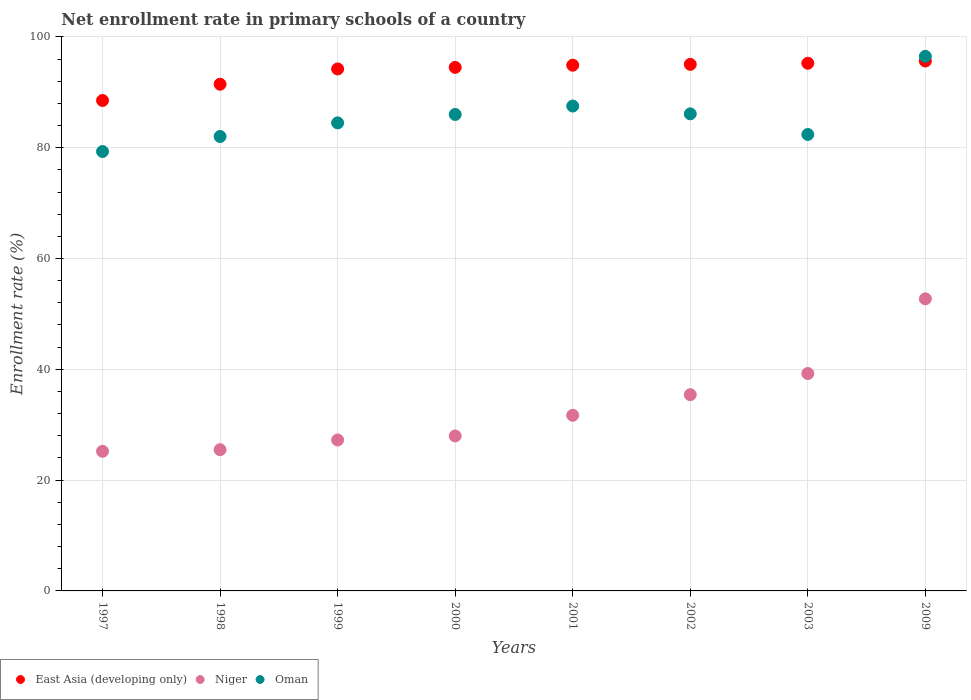What is the enrollment rate in primary schools in East Asia (developing only) in 1998?
Offer a very short reply. 91.46. Across all years, what is the maximum enrollment rate in primary schools in Niger?
Your answer should be very brief. 52.72. Across all years, what is the minimum enrollment rate in primary schools in Oman?
Make the answer very short. 79.31. In which year was the enrollment rate in primary schools in East Asia (developing only) minimum?
Your answer should be compact. 1997. What is the total enrollment rate in primary schools in Oman in the graph?
Your response must be concise. 684.31. What is the difference between the enrollment rate in primary schools in East Asia (developing only) in 1999 and that in 2009?
Offer a terse response. -1.43. What is the difference between the enrollment rate in primary schools in Niger in 2002 and the enrollment rate in primary schools in East Asia (developing only) in 2001?
Keep it short and to the point. -59.47. What is the average enrollment rate in primary schools in Oman per year?
Your answer should be compact. 85.54. In the year 2000, what is the difference between the enrollment rate in primary schools in Oman and enrollment rate in primary schools in Niger?
Make the answer very short. 58.03. What is the ratio of the enrollment rate in primary schools in East Asia (developing only) in 2002 to that in 2009?
Keep it short and to the point. 0.99. What is the difference between the highest and the second highest enrollment rate in primary schools in Oman?
Your response must be concise. 8.97. What is the difference between the highest and the lowest enrollment rate in primary schools in Niger?
Give a very brief answer. 27.52. Is the sum of the enrollment rate in primary schools in East Asia (developing only) in 1998 and 2000 greater than the maximum enrollment rate in primary schools in Niger across all years?
Your response must be concise. Yes. Does the enrollment rate in primary schools in Oman monotonically increase over the years?
Offer a terse response. No. Is the enrollment rate in primary schools in East Asia (developing only) strictly greater than the enrollment rate in primary schools in Niger over the years?
Provide a succinct answer. Yes. Is the enrollment rate in primary schools in Oman strictly less than the enrollment rate in primary schools in East Asia (developing only) over the years?
Your answer should be compact. No. How many years are there in the graph?
Offer a very short reply. 8. Are the values on the major ticks of Y-axis written in scientific E-notation?
Your answer should be very brief. No. Does the graph contain grids?
Provide a succinct answer. Yes. Where does the legend appear in the graph?
Offer a terse response. Bottom left. What is the title of the graph?
Give a very brief answer. Net enrollment rate in primary schools of a country. Does "St. Lucia" appear as one of the legend labels in the graph?
Your response must be concise. No. What is the label or title of the X-axis?
Offer a terse response. Years. What is the label or title of the Y-axis?
Your response must be concise. Enrollment rate (%). What is the Enrollment rate (%) in East Asia (developing only) in 1997?
Your answer should be very brief. 88.52. What is the Enrollment rate (%) of Niger in 1997?
Offer a terse response. 25.2. What is the Enrollment rate (%) of Oman in 1997?
Make the answer very short. 79.31. What is the Enrollment rate (%) of East Asia (developing only) in 1998?
Offer a very short reply. 91.46. What is the Enrollment rate (%) in Niger in 1998?
Ensure brevity in your answer.  25.49. What is the Enrollment rate (%) of Oman in 1998?
Ensure brevity in your answer.  82.02. What is the Enrollment rate (%) in East Asia (developing only) in 1999?
Make the answer very short. 94.21. What is the Enrollment rate (%) in Niger in 1999?
Offer a very short reply. 27.24. What is the Enrollment rate (%) in Oman in 1999?
Keep it short and to the point. 84.48. What is the Enrollment rate (%) in East Asia (developing only) in 2000?
Keep it short and to the point. 94.5. What is the Enrollment rate (%) in Niger in 2000?
Your answer should be compact. 27.97. What is the Enrollment rate (%) of Oman in 2000?
Ensure brevity in your answer.  86. What is the Enrollment rate (%) in East Asia (developing only) in 2001?
Your response must be concise. 94.89. What is the Enrollment rate (%) of Niger in 2001?
Your answer should be very brief. 31.7. What is the Enrollment rate (%) in Oman in 2001?
Provide a succinct answer. 87.52. What is the Enrollment rate (%) in East Asia (developing only) in 2002?
Make the answer very short. 95.04. What is the Enrollment rate (%) of Niger in 2002?
Your answer should be very brief. 35.42. What is the Enrollment rate (%) in Oman in 2002?
Make the answer very short. 86.11. What is the Enrollment rate (%) in East Asia (developing only) in 2003?
Make the answer very short. 95.24. What is the Enrollment rate (%) in Niger in 2003?
Provide a short and direct response. 39.24. What is the Enrollment rate (%) in Oman in 2003?
Offer a very short reply. 82.39. What is the Enrollment rate (%) in East Asia (developing only) in 2009?
Provide a succinct answer. 95.64. What is the Enrollment rate (%) of Niger in 2009?
Ensure brevity in your answer.  52.72. What is the Enrollment rate (%) of Oman in 2009?
Your answer should be compact. 96.49. Across all years, what is the maximum Enrollment rate (%) in East Asia (developing only)?
Offer a terse response. 95.64. Across all years, what is the maximum Enrollment rate (%) of Niger?
Your answer should be compact. 52.72. Across all years, what is the maximum Enrollment rate (%) in Oman?
Your answer should be very brief. 96.49. Across all years, what is the minimum Enrollment rate (%) in East Asia (developing only)?
Offer a terse response. 88.52. Across all years, what is the minimum Enrollment rate (%) of Niger?
Your answer should be very brief. 25.2. Across all years, what is the minimum Enrollment rate (%) in Oman?
Make the answer very short. 79.31. What is the total Enrollment rate (%) of East Asia (developing only) in the graph?
Provide a short and direct response. 749.5. What is the total Enrollment rate (%) in Niger in the graph?
Make the answer very short. 264.98. What is the total Enrollment rate (%) in Oman in the graph?
Ensure brevity in your answer.  684.31. What is the difference between the Enrollment rate (%) in East Asia (developing only) in 1997 and that in 1998?
Give a very brief answer. -2.93. What is the difference between the Enrollment rate (%) of Niger in 1997 and that in 1998?
Make the answer very short. -0.29. What is the difference between the Enrollment rate (%) in Oman in 1997 and that in 1998?
Offer a very short reply. -2.71. What is the difference between the Enrollment rate (%) in East Asia (developing only) in 1997 and that in 1999?
Offer a terse response. -5.69. What is the difference between the Enrollment rate (%) in Niger in 1997 and that in 1999?
Offer a terse response. -2.04. What is the difference between the Enrollment rate (%) of Oman in 1997 and that in 1999?
Offer a very short reply. -5.17. What is the difference between the Enrollment rate (%) in East Asia (developing only) in 1997 and that in 2000?
Give a very brief answer. -5.97. What is the difference between the Enrollment rate (%) of Niger in 1997 and that in 2000?
Offer a very short reply. -2.77. What is the difference between the Enrollment rate (%) of Oman in 1997 and that in 2000?
Your answer should be compact. -6.69. What is the difference between the Enrollment rate (%) of East Asia (developing only) in 1997 and that in 2001?
Keep it short and to the point. -6.37. What is the difference between the Enrollment rate (%) in Niger in 1997 and that in 2001?
Ensure brevity in your answer.  -6.5. What is the difference between the Enrollment rate (%) of Oman in 1997 and that in 2001?
Your answer should be very brief. -8.21. What is the difference between the Enrollment rate (%) of East Asia (developing only) in 1997 and that in 2002?
Your response must be concise. -6.52. What is the difference between the Enrollment rate (%) of Niger in 1997 and that in 2002?
Give a very brief answer. -10.22. What is the difference between the Enrollment rate (%) in Oman in 1997 and that in 2002?
Offer a very short reply. -6.8. What is the difference between the Enrollment rate (%) in East Asia (developing only) in 1997 and that in 2003?
Provide a succinct answer. -6.72. What is the difference between the Enrollment rate (%) of Niger in 1997 and that in 2003?
Offer a very short reply. -14.04. What is the difference between the Enrollment rate (%) in Oman in 1997 and that in 2003?
Keep it short and to the point. -3.08. What is the difference between the Enrollment rate (%) of East Asia (developing only) in 1997 and that in 2009?
Offer a very short reply. -7.12. What is the difference between the Enrollment rate (%) in Niger in 1997 and that in 2009?
Make the answer very short. -27.52. What is the difference between the Enrollment rate (%) in Oman in 1997 and that in 2009?
Ensure brevity in your answer.  -17.18. What is the difference between the Enrollment rate (%) in East Asia (developing only) in 1998 and that in 1999?
Your answer should be compact. -2.76. What is the difference between the Enrollment rate (%) of Niger in 1998 and that in 1999?
Ensure brevity in your answer.  -1.75. What is the difference between the Enrollment rate (%) in Oman in 1998 and that in 1999?
Make the answer very short. -2.46. What is the difference between the Enrollment rate (%) in East Asia (developing only) in 1998 and that in 2000?
Your answer should be compact. -3.04. What is the difference between the Enrollment rate (%) in Niger in 1998 and that in 2000?
Give a very brief answer. -2.48. What is the difference between the Enrollment rate (%) of Oman in 1998 and that in 2000?
Your response must be concise. -3.98. What is the difference between the Enrollment rate (%) of East Asia (developing only) in 1998 and that in 2001?
Your answer should be compact. -3.43. What is the difference between the Enrollment rate (%) in Niger in 1998 and that in 2001?
Keep it short and to the point. -6.21. What is the difference between the Enrollment rate (%) in Oman in 1998 and that in 2001?
Provide a short and direct response. -5.5. What is the difference between the Enrollment rate (%) in East Asia (developing only) in 1998 and that in 2002?
Keep it short and to the point. -3.58. What is the difference between the Enrollment rate (%) in Niger in 1998 and that in 2002?
Offer a terse response. -9.93. What is the difference between the Enrollment rate (%) in Oman in 1998 and that in 2002?
Make the answer very short. -4.09. What is the difference between the Enrollment rate (%) in East Asia (developing only) in 1998 and that in 2003?
Offer a very short reply. -3.79. What is the difference between the Enrollment rate (%) in Niger in 1998 and that in 2003?
Offer a terse response. -13.75. What is the difference between the Enrollment rate (%) of Oman in 1998 and that in 2003?
Offer a very short reply. -0.37. What is the difference between the Enrollment rate (%) of East Asia (developing only) in 1998 and that in 2009?
Your answer should be very brief. -4.19. What is the difference between the Enrollment rate (%) in Niger in 1998 and that in 2009?
Ensure brevity in your answer.  -27.23. What is the difference between the Enrollment rate (%) in Oman in 1998 and that in 2009?
Offer a very short reply. -14.47. What is the difference between the Enrollment rate (%) in East Asia (developing only) in 1999 and that in 2000?
Ensure brevity in your answer.  -0.28. What is the difference between the Enrollment rate (%) in Niger in 1999 and that in 2000?
Your answer should be very brief. -0.73. What is the difference between the Enrollment rate (%) in Oman in 1999 and that in 2000?
Your answer should be very brief. -1.52. What is the difference between the Enrollment rate (%) in East Asia (developing only) in 1999 and that in 2001?
Provide a short and direct response. -0.68. What is the difference between the Enrollment rate (%) in Niger in 1999 and that in 2001?
Provide a short and direct response. -4.46. What is the difference between the Enrollment rate (%) of Oman in 1999 and that in 2001?
Offer a very short reply. -3.04. What is the difference between the Enrollment rate (%) of East Asia (developing only) in 1999 and that in 2002?
Give a very brief answer. -0.83. What is the difference between the Enrollment rate (%) in Niger in 1999 and that in 2002?
Your response must be concise. -8.18. What is the difference between the Enrollment rate (%) of Oman in 1999 and that in 2002?
Give a very brief answer. -1.63. What is the difference between the Enrollment rate (%) of East Asia (developing only) in 1999 and that in 2003?
Offer a very short reply. -1.03. What is the difference between the Enrollment rate (%) of Niger in 1999 and that in 2003?
Make the answer very short. -12. What is the difference between the Enrollment rate (%) in Oman in 1999 and that in 2003?
Offer a very short reply. 2.09. What is the difference between the Enrollment rate (%) in East Asia (developing only) in 1999 and that in 2009?
Provide a short and direct response. -1.43. What is the difference between the Enrollment rate (%) in Niger in 1999 and that in 2009?
Keep it short and to the point. -25.47. What is the difference between the Enrollment rate (%) of Oman in 1999 and that in 2009?
Give a very brief answer. -12.01. What is the difference between the Enrollment rate (%) in East Asia (developing only) in 2000 and that in 2001?
Provide a short and direct response. -0.39. What is the difference between the Enrollment rate (%) of Niger in 2000 and that in 2001?
Offer a very short reply. -3.73. What is the difference between the Enrollment rate (%) in Oman in 2000 and that in 2001?
Offer a terse response. -1.52. What is the difference between the Enrollment rate (%) of East Asia (developing only) in 2000 and that in 2002?
Make the answer very short. -0.54. What is the difference between the Enrollment rate (%) in Niger in 2000 and that in 2002?
Your response must be concise. -7.45. What is the difference between the Enrollment rate (%) of Oman in 2000 and that in 2002?
Offer a very short reply. -0.11. What is the difference between the Enrollment rate (%) of East Asia (developing only) in 2000 and that in 2003?
Your response must be concise. -0.75. What is the difference between the Enrollment rate (%) of Niger in 2000 and that in 2003?
Offer a terse response. -11.27. What is the difference between the Enrollment rate (%) of Oman in 2000 and that in 2003?
Your response must be concise. 3.61. What is the difference between the Enrollment rate (%) of East Asia (developing only) in 2000 and that in 2009?
Offer a very short reply. -1.15. What is the difference between the Enrollment rate (%) in Niger in 2000 and that in 2009?
Provide a short and direct response. -24.75. What is the difference between the Enrollment rate (%) of Oman in 2000 and that in 2009?
Offer a very short reply. -10.49. What is the difference between the Enrollment rate (%) of East Asia (developing only) in 2001 and that in 2002?
Provide a succinct answer. -0.15. What is the difference between the Enrollment rate (%) in Niger in 2001 and that in 2002?
Provide a short and direct response. -3.72. What is the difference between the Enrollment rate (%) in Oman in 2001 and that in 2002?
Offer a very short reply. 1.41. What is the difference between the Enrollment rate (%) of East Asia (developing only) in 2001 and that in 2003?
Keep it short and to the point. -0.35. What is the difference between the Enrollment rate (%) in Niger in 2001 and that in 2003?
Offer a very short reply. -7.54. What is the difference between the Enrollment rate (%) of Oman in 2001 and that in 2003?
Provide a short and direct response. 5.13. What is the difference between the Enrollment rate (%) of East Asia (developing only) in 2001 and that in 2009?
Offer a very short reply. -0.76. What is the difference between the Enrollment rate (%) in Niger in 2001 and that in 2009?
Offer a terse response. -21.02. What is the difference between the Enrollment rate (%) of Oman in 2001 and that in 2009?
Offer a very short reply. -8.97. What is the difference between the Enrollment rate (%) in East Asia (developing only) in 2002 and that in 2003?
Ensure brevity in your answer.  -0.2. What is the difference between the Enrollment rate (%) in Niger in 2002 and that in 2003?
Provide a succinct answer. -3.82. What is the difference between the Enrollment rate (%) of Oman in 2002 and that in 2003?
Provide a short and direct response. 3.73. What is the difference between the Enrollment rate (%) of East Asia (developing only) in 2002 and that in 2009?
Ensure brevity in your answer.  -0.6. What is the difference between the Enrollment rate (%) of Niger in 2002 and that in 2009?
Offer a terse response. -17.3. What is the difference between the Enrollment rate (%) in Oman in 2002 and that in 2009?
Make the answer very short. -10.38. What is the difference between the Enrollment rate (%) of East Asia (developing only) in 2003 and that in 2009?
Provide a short and direct response. -0.4. What is the difference between the Enrollment rate (%) in Niger in 2003 and that in 2009?
Offer a very short reply. -13.48. What is the difference between the Enrollment rate (%) in Oman in 2003 and that in 2009?
Give a very brief answer. -14.1. What is the difference between the Enrollment rate (%) of East Asia (developing only) in 1997 and the Enrollment rate (%) of Niger in 1998?
Your answer should be compact. 63.03. What is the difference between the Enrollment rate (%) in East Asia (developing only) in 1997 and the Enrollment rate (%) in Oman in 1998?
Your answer should be compact. 6.5. What is the difference between the Enrollment rate (%) in Niger in 1997 and the Enrollment rate (%) in Oman in 1998?
Offer a terse response. -56.82. What is the difference between the Enrollment rate (%) of East Asia (developing only) in 1997 and the Enrollment rate (%) of Niger in 1999?
Give a very brief answer. 61.28. What is the difference between the Enrollment rate (%) in East Asia (developing only) in 1997 and the Enrollment rate (%) in Oman in 1999?
Keep it short and to the point. 4.04. What is the difference between the Enrollment rate (%) in Niger in 1997 and the Enrollment rate (%) in Oman in 1999?
Your response must be concise. -59.28. What is the difference between the Enrollment rate (%) in East Asia (developing only) in 1997 and the Enrollment rate (%) in Niger in 2000?
Give a very brief answer. 60.55. What is the difference between the Enrollment rate (%) of East Asia (developing only) in 1997 and the Enrollment rate (%) of Oman in 2000?
Make the answer very short. 2.52. What is the difference between the Enrollment rate (%) of Niger in 1997 and the Enrollment rate (%) of Oman in 2000?
Offer a terse response. -60.8. What is the difference between the Enrollment rate (%) in East Asia (developing only) in 1997 and the Enrollment rate (%) in Niger in 2001?
Give a very brief answer. 56.82. What is the difference between the Enrollment rate (%) of East Asia (developing only) in 1997 and the Enrollment rate (%) of Oman in 2001?
Give a very brief answer. 1. What is the difference between the Enrollment rate (%) in Niger in 1997 and the Enrollment rate (%) in Oman in 2001?
Make the answer very short. -62.32. What is the difference between the Enrollment rate (%) in East Asia (developing only) in 1997 and the Enrollment rate (%) in Niger in 2002?
Keep it short and to the point. 53.1. What is the difference between the Enrollment rate (%) in East Asia (developing only) in 1997 and the Enrollment rate (%) in Oman in 2002?
Keep it short and to the point. 2.41. What is the difference between the Enrollment rate (%) of Niger in 1997 and the Enrollment rate (%) of Oman in 2002?
Offer a very short reply. -60.91. What is the difference between the Enrollment rate (%) of East Asia (developing only) in 1997 and the Enrollment rate (%) of Niger in 2003?
Your answer should be compact. 49.28. What is the difference between the Enrollment rate (%) of East Asia (developing only) in 1997 and the Enrollment rate (%) of Oman in 2003?
Your answer should be very brief. 6.14. What is the difference between the Enrollment rate (%) in Niger in 1997 and the Enrollment rate (%) in Oman in 2003?
Your response must be concise. -57.19. What is the difference between the Enrollment rate (%) of East Asia (developing only) in 1997 and the Enrollment rate (%) of Niger in 2009?
Your answer should be very brief. 35.8. What is the difference between the Enrollment rate (%) of East Asia (developing only) in 1997 and the Enrollment rate (%) of Oman in 2009?
Offer a very short reply. -7.97. What is the difference between the Enrollment rate (%) of Niger in 1997 and the Enrollment rate (%) of Oman in 2009?
Your answer should be very brief. -71.29. What is the difference between the Enrollment rate (%) in East Asia (developing only) in 1998 and the Enrollment rate (%) in Niger in 1999?
Keep it short and to the point. 64.21. What is the difference between the Enrollment rate (%) in East Asia (developing only) in 1998 and the Enrollment rate (%) in Oman in 1999?
Provide a short and direct response. 6.98. What is the difference between the Enrollment rate (%) of Niger in 1998 and the Enrollment rate (%) of Oman in 1999?
Your answer should be very brief. -58.99. What is the difference between the Enrollment rate (%) of East Asia (developing only) in 1998 and the Enrollment rate (%) of Niger in 2000?
Your answer should be very brief. 63.49. What is the difference between the Enrollment rate (%) in East Asia (developing only) in 1998 and the Enrollment rate (%) in Oman in 2000?
Give a very brief answer. 5.46. What is the difference between the Enrollment rate (%) of Niger in 1998 and the Enrollment rate (%) of Oman in 2000?
Offer a terse response. -60.51. What is the difference between the Enrollment rate (%) of East Asia (developing only) in 1998 and the Enrollment rate (%) of Niger in 2001?
Provide a short and direct response. 59.75. What is the difference between the Enrollment rate (%) in East Asia (developing only) in 1998 and the Enrollment rate (%) in Oman in 2001?
Make the answer very short. 3.94. What is the difference between the Enrollment rate (%) of Niger in 1998 and the Enrollment rate (%) of Oman in 2001?
Provide a succinct answer. -62.03. What is the difference between the Enrollment rate (%) in East Asia (developing only) in 1998 and the Enrollment rate (%) in Niger in 2002?
Make the answer very short. 56.04. What is the difference between the Enrollment rate (%) of East Asia (developing only) in 1998 and the Enrollment rate (%) of Oman in 2002?
Keep it short and to the point. 5.34. What is the difference between the Enrollment rate (%) of Niger in 1998 and the Enrollment rate (%) of Oman in 2002?
Ensure brevity in your answer.  -60.62. What is the difference between the Enrollment rate (%) of East Asia (developing only) in 1998 and the Enrollment rate (%) of Niger in 2003?
Ensure brevity in your answer.  52.22. What is the difference between the Enrollment rate (%) in East Asia (developing only) in 1998 and the Enrollment rate (%) in Oman in 2003?
Ensure brevity in your answer.  9.07. What is the difference between the Enrollment rate (%) in Niger in 1998 and the Enrollment rate (%) in Oman in 2003?
Offer a very short reply. -56.9. What is the difference between the Enrollment rate (%) of East Asia (developing only) in 1998 and the Enrollment rate (%) of Niger in 2009?
Offer a very short reply. 38.74. What is the difference between the Enrollment rate (%) in East Asia (developing only) in 1998 and the Enrollment rate (%) in Oman in 2009?
Your answer should be very brief. -5.04. What is the difference between the Enrollment rate (%) of Niger in 1998 and the Enrollment rate (%) of Oman in 2009?
Offer a very short reply. -71. What is the difference between the Enrollment rate (%) in East Asia (developing only) in 1999 and the Enrollment rate (%) in Niger in 2000?
Your response must be concise. 66.24. What is the difference between the Enrollment rate (%) of East Asia (developing only) in 1999 and the Enrollment rate (%) of Oman in 2000?
Offer a terse response. 8.22. What is the difference between the Enrollment rate (%) of Niger in 1999 and the Enrollment rate (%) of Oman in 2000?
Make the answer very short. -58.75. What is the difference between the Enrollment rate (%) of East Asia (developing only) in 1999 and the Enrollment rate (%) of Niger in 2001?
Your answer should be compact. 62.51. What is the difference between the Enrollment rate (%) in East Asia (developing only) in 1999 and the Enrollment rate (%) in Oman in 2001?
Ensure brevity in your answer.  6.7. What is the difference between the Enrollment rate (%) in Niger in 1999 and the Enrollment rate (%) in Oman in 2001?
Offer a very short reply. -60.27. What is the difference between the Enrollment rate (%) of East Asia (developing only) in 1999 and the Enrollment rate (%) of Niger in 2002?
Offer a terse response. 58.79. What is the difference between the Enrollment rate (%) of East Asia (developing only) in 1999 and the Enrollment rate (%) of Oman in 2002?
Provide a short and direct response. 8.1. What is the difference between the Enrollment rate (%) of Niger in 1999 and the Enrollment rate (%) of Oman in 2002?
Offer a very short reply. -58.87. What is the difference between the Enrollment rate (%) in East Asia (developing only) in 1999 and the Enrollment rate (%) in Niger in 2003?
Make the answer very short. 54.97. What is the difference between the Enrollment rate (%) in East Asia (developing only) in 1999 and the Enrollment rate (%) in Oman in 2003?
Provide a short and direct response. 11.83. What is the difference between the Enrollment rate (%) in Niger in 1999 and the Enrollment rate (%) in Oman in 2003?
Offer a very short reply. -55.14. What is the difference between the Enrollment rate (%) of East Asia (developing only) in 1999 and the Enrollment rate (%) of Niger in 2009?
Offer a very short reply. 41.5. What is the difference between the Enrollment rate (%) of East Asia (developing only) in 1999 and the Enrollment rate (%) of Oman in 2009?
Provide a short and direct response. -2.28. What is the difference between the Enrollment rate (%) in Niger in 1999 and the Enrollment rate (%) in Oman in 2009?
Your answer should be very brief. -69.25. What is the difference between the Enrollment rate (%) of East Asia (developing only) in 2000 and the Enrollment rate (%) of Niger in 2001?
Your answer should be very brief. 62.8. What is the difference between the Enrollment rate (%) in East Asia (developing only) in 2000 and the Enrollment rate (%) in Oman in 2001?
Offer a terse response. 6.98. What is the difference between the Enrollment rate (%) of Niger in 2000 and the Enrollment rate (%) of Oman in 2001?
Offer a very short reply. -59.55. What is the difference between the Enrollment rate (%) of East Asia (developing only) in 2000 and the Enrollment rate (%) of Niger in 2002?
Provide a short and direct response. 59.08. What is the difference between the Enrollment rate (%) in East Asia (developing only) in 2000 and the Enrollment rate (%) in Oman in 2002?
Make the answer very short. 8.38. What is the difference between the Enrollment rate (%) of Niger in 2000 and the Enrollment rate (%) of Oman in 2002?
Ensure brevity in your answer.  -58.14. What is the difference between the Enrollment rate (%) of East Asia (developing only) in 2000 and the Enrollment rate (%) of Niger in 2003?
Provide a short and direct response. 55.26. What is the difference between the Enrollment rate (%) in East Asia (developing only) in 2000 and the Enrollment rate (%) in Oman in 2003?
Give a very brief answer. 12.11. What is the difference between the Enrollment rate (%) in Niger in 2000 and the Enrollment rate (%) in Oman in 2003?
Make the answer very short. -54.42. What is the difference between the Enrollment rate (%) of East Asia (developing only) in 2000 and the Enrollment rate (%) of Niger in 2009?
Your answer should be compact. 41.78. What is the difference between the Enrollment rate (%) of East Asia (developing only) in 2000 and the Enrollment rate (%) of Oman in 2009?
Keep it short and to the point. -1.99. What is the difference between the Enrollment rate (%) in Niger in 2000 and the Enrollment rate (%) in Oman in 2009?
Make the answer very short. -68.52. What is the difference between the Enrollment rate (%) of East Asia (developing only) in 2001 and the Enrollment rate (%) of Niger in 2002?
Provide a short and direct response. 59.47. What is the difference between the Enrollment rate (%) in East Asia (developing only) in 2001 and the Enrollment rate (%) in Oman in 2002?
Make the answer very short. 8.78. What is the difference between the Enrollment rate (%) in Niger in 2001 and the Enrollment rate (%) in Oman in 2002?
Your response must be concise. -54.41. What is the difference between the Enrollment rate (%) in East Asia (developing only) in 2001 and the Enrollment rate (%) in Niger in 2003?
Offer a very short reply. 55.65. What is the difference between the Enrollment rate (%) in East Asia (developing only) in 2001 and the Enrollment rate (%) in Oman in 2003?
Ensure brevity in your answer.  12.5. What is the difference between the Enrollment rate (%) in Niger in 2001 and the Enrollment rate (%) in Oman in 2003?
Offer a terse response. -50.69. What is the difference between the Enrollment rate (%) of East Asia (developing only) in 2001 and the Enrollment rate (%) of Niger in 2009?
Your response must be concise. 42.17. What is the difference between the Enrollment rate (%) in East Asia (developing only) in 2001 and the Enrollment rate (%) in Oman in 2009?
Your answer should be compact. -1.6. What is the difference between the Enrollment rate (%) in Niger in 2001 and the Enrollment rate (%) in Oman in 2009?
Ensure brevity in your answer.  -64.79. What is the difference between the Enrollment rate (%) in East Asia (developing only) in 2002 and the Enrollment rate (%) in Niger in 2003?
Ensure brevity in your answer.  55.8. What is the difference between the Enrollment rate (%) of East Asia (developing only) in 2002 and the Enrollment rate (%) of Oman in 2003?
Provide a succinct answer. 12.65. What is the difference between the Enrollment rate (%) in Niger in 2002 and the Enrollment rate (%) in Oman in 2003?
Provide a short and direct response. -46.97. What is the difference between the Enrollment rate (%) in East Asia (developing only) in 2002 and the Enrollment rate (%) in Niger in 2009?
Provide a succinct answer. 42.32. What is the difference between the Enrollment rate (%) of East Asia (developing only) in 2002 and the Enrollment rate (%) of Oman in 2009?
Ensure brevity in your answer.  -1.45. What is the difference between the Enrollment rate (%) in Niger in 2002 and the Enrollment rate (%) in Oman in 2009?
Ensure brevity in your answer.  -61.07. What is the difference between the Enrollment rate (%) of East Asia (developing only) in 2003 and the Enrollment rate (%) of Niger in 2009?
Make the answer very short. 42.53. What is the difference between the Enrollment rate (%) of East Asia (developing only) in 2003 and the Enrollment rate (%) of Oman in 2009?
Offer a terse response. -1.25. What is the difference between the Enrollment rate (%) of Niger in 2003 and the Enrollment rate (%) of Oman in 2009?
Provide a succinct answer. -57.25. What is the average Enrollment rate (%) in East Asia (developing only) per year?
Provide a short and direct response. 93.69. What is the average Enrollment rate (%) in Niger per year?
Make the answer very short. 33.12. What is the average Enrollment rate (%) in Oman per year?
Provide a succinct answer. 85.54. In the year 1997, what is the difference between the Enrollment rate (%) of East Asia (developing only) and Enrollment rate (%) of Niger?
Provide a succinct answer. 63.32. In the year 1997, what is the difference between the Enrollment rate (%) in East Asia (developing only) and Enrollment rate (%) in Oman?
Your response must be concise. 9.21. In the year 1997, what is the difference between the Enrollment rate (%) of Niger and Enrollment rate (%) of Oman?
Provide a succinct answer. -54.11. In the year 1998, what is the difference between the Enrollment rate (%) of East Asia (developing only) and Enrollment rate (%) of Niger?
Offer a very short reply. 65.97. In the year 1998, what is the difference between the Enrollment rate (%) in East Asia (developing only) and Enrollment rate (%) in Oman?
Make the answer very short. 9.44. In the year 1998, what is the difference between the Enrollment rate (%) in Niger and Enrollment rate (%) in Oman?
Offer a terse response. -56.53. In the year 1999, what is the difference between the Enrollment rate (%) in East Asia (developing only) and Enrollment rate (%) in Niger?
Your response must be concise. 66.97. In the year 1999, what is the difference between the Enrollment rate (%) of East Asia (developing only) and Enrollment rate (%) of Oman?
Make the answer very short. 9.73. In the year 1999, what is the difference between the Enrollment rate (%) in Niger and Enrollment rate (%) in Oman?
Your answer should be very brief. -57.24. In the year 2000, what is the difference between the Enrollment rate (%) of East Asia (developing only) and Enrollment rate (%) of Niger?
Your response must be concise. 66.53. In the year 2000, what is the difference between the Enrollment rate (%) of East Asia (developing only) and Enrollment rate (%) of Oman?
Your answer should be very brief. 8.5. In the year 2000, what is the difference between the Enrollment rate (%) of Niger and Enrollment rate (%) of Oman?
Make the answer very short. -58.03. In the year 2001, what is the difference between the Enrollment rate (%) of East Asia (developing only) and Enrollment rate (%) of Niger?
Give a very brief answer. 63.19. In the year 2001, what is the difference between the Enrollment rate (%) of East Asia (developing only) and Enrollment rate (%) of Oman?
Offer a very short reply. 7.37. In the year 2001, what is the difference between the Enrollment rate (%) of Niger and Enrollment rate (%) of Oman?
Offer a terse response. -55.82. In the year 2002, what is the difference between the Enrollment rate (%) of East Asia (developing only) and Enrollment rate (%) of Niger?
Give a very brief answer. 59.62. In the year 2002, what is the difference between the Enrollment rate (%) of East Asia (developing only) and Enrollment rate (%) of Oman?
Offer a terse response. 8.93. In the year 2002, what is the difference between the Enrollment rate (%) of Niger and Enrollment rate (%) of Oman?
Provide a succinct answer. -50.69. In the year 2003, what is the difference between the Enrollment rate (%) in East Asia (developing only) and Enrollment rate (%) in Niger?
Offer a very short reply. 56. In the year 2003, what is the difference between the Enrollment rate (%) in East Asia (developing only) and Enrollment rate (%) in Oman?
Your answer should be very brief. 12.86. In the year 2003, what is the difference between the Enrollment rate (%) in Niger and Enrollment rate (%) in Oman?
Your answer should be very brief. -43.15. In the year 2009, what is the difference between the Enrollment rate (%) in East Asia (developing only) and Enrollment rate (%) in Niger?
Give a very brief answer. 42.93. In the year 2009, what is the difference between the Enrollment rate (%) of East Asia (developing only) and Enrollment rate (%) of Oman?
Give a very brief answer. -0.85. In the year 2009, what is the difference between the Enrollment rate (%) in Niger and Enrollment rate (%) in Oman?
Ensure brevity in your answer.  -43.77. What is the ratio of the Enrollment rate (%) in East Asia (developing only) in 1997 to that in 1998?
Keep it short and to the point. 0.97. What is the ratio of the Enrollment rate (%) of East Asia (developing only) in 1997 to that in 1999?
Your answer should be compact. 0.94. What is the ratio of the Enrollment rate (%) of Niger in 1997 to that in 1999?
Make the answer very short. 0.93. What is the ratio of the Enrollment rate (%) of Oman in 1997 to that in 1999?
Offer a very short reply. 0.94. What is the ratio of the Enrollment rate (%) of East Asia (developing only) in 1997 to that in 2000?
Your answer should be compact. 0.94. What is the ratio of the Enrollment rate (%) in Niger in 1997 to that in 2000?
Your response must be concise. 0.9. What is the ratio of the Enrollment rate (%) of Oman in 1997 to that in 2000?
Your response must be concise. 0.92. What is the ratio of the Enrollment rate (%) of East Asia (developing only) in 1997 to that in 2001?
Give a very brief answer. 0.93. What is the ratio of the Enrollment rate (%) of Niger in 1997 to that in 2001?
Make the answer very short. 0.79. What is the ratio of the Enrollment rate (%) of Oman in 1997 to that in 2001?
Offer a very short reply. 0.91. What is the ratio of the Enrollment rate (%) in East Asia (developing only) in 1997 to that in 2002?
Your answer should be compact. 0.93. What is the ratio of the Enrollment rate (%) of Niger in 1997 to that in 2002?
Provide a succinct answer. 0.71. What is the ratio of the Enrollment rate (%) in Oman in 1997 to that in 2002?
Offer a terse response. 0.92. What is the ratio of the Enrollment rate (%) in East Asia (developing only) in 1997 to that in 2003?
Your answer should be very brief. 0.93. What is the ratio of the Enrollment rate (%) of Niger in 1997 to that in 2003?
Your response must be concise. 0.64. What is the ratio of the Enrollment rate (%) in Oman in 1997 to that in 2003?
Give a very brief answer. 0.96. What is the ratio of the Enrollment rate (%) in East Asia (developing only) in 1997 to that in 2009?
Your answer should be compact. 0.93. What is the ratio of the Enrollment rate (%) of Niger in 1997 to that in 2009?
Keep it short and to the point. 0.48. What is the ratio of the Enrollment rate (%) of Oman in 1997 to that in 2009?
Your answer should be compact. 0.82. What is the ratio of the Enrollment rate (%) in East Asia (developing only) in 1998 to that in 1999?
Your response must be concise. 0.97. What is the ratio of the Enrollment rate (%) of Niger in 1998 to that in 1999?
Your answer should be compact. 0.94. What is the ratio of the Enrollment rate (%) of Oman in 1998 to that in 1999?
Make the answer very short. 0.97. What is the ratio of the Enrollment rate (%) in East Asia (developing only) in 1998 to that in 2000?
Offer a very short reply. 0.97. What is the ratio of the Enrollment rate (%) of Niger in 1998 to that in 2000?
Keep it short and to the point. 0.91. What is the ratio of the Enrollment rate (%) of Oman in 1998 to that in 2000?
Provide a succinct answer. 0.95. What is the ratio of the Enrollment rate (%) in East Asia (developing only) in 1998 to that in 2001?
Offer a very short reply. 0.96. What is the ratio of the Enrollment rate (%) of Niger in 1998 to that in 2001?
Ensure brevity in your answer.  0.8. What is the ratio of the Enrollment rate (%) in Oman in 1998 to that in 2001?
Offer a terse response. 0.94. What is the ratio of the Enrollment rate (%) of East Asia (developing only) in 1998 to that in 2002?
Provide a short and direct response. 0.96. What is the ratio of the Enrollment rate (%) in Niger in 1998 to that in 2002?
Keep it short and to the point. 0.72. What is the ratio of the Enrollment rate (%) of Oman in 1998 to that in 2002?
Offer a very short reply. 0.95. What is the ratio of the Enrollment rate (%) of East Asia (developing only) in 1998 to that in 2003?
Your response must be concise. 0.96. What is the ratio of the Enrollment rate (%) of Niger in 1998 to that in 2003?
Provide a short and direct response. 0.65. What is the ratio of the Enrollment rate (%) of East Asia (developing only) in 1998 to that in 2009?
Offer a very short reply. 0.96. What is the ratio of the Enrollment rate (%) in Niger in 1998 to that in 2009?
Make the answer very short. 0.48. What is the ratio of the Enrollment rate (%) in East Asia (developing only) in 1999 to that in 2000?
Provide a short and direct response. 1. What is the ratio of the Enrollment rate (%) of Oman in 1999 to that in 2000?
Your answer should be very brief. 0.98. What is the ratio of the Enrollment rate (%) of East Asia (developing only) in 1999 to that in 2001?
Offer a terse response. 0.99. What is the ratio of the Enrollment rate (%) of Niger in 1999 to that in 2001?
Your answer should be compact. 0.86. What is the ratio of the Enrollment rate (%) in Oman in 1999 to that in 2001?
Give a very brief answer. 0.97. What is the ratio of the Enrollment rate (%) in Niger in 1999 to that in 2002?
Give a very brief answer. 0.77. What is the ratio of the Enrollment rate (%) of East Asia (developing only) in 1999 to that in 2003?
Make the answer very short. 0.99. What is the ratio of the Enrollment rate (%) of Niger in 1999 to that in 2003?
Your answer should be very brief. 0.69. What is the ratio of the Enrollment rate (%) in Oman in 1999 to that in 2003?
Your answer should be very brief. 1.03. What is the ratio of the Enrollment rate (%) in East Asia (developing only) in 1999 to that in 2009?
Your answer should be compact. 0.98. What is the ratio of the Enrollment rate (%) in Niger in 1999 to that in 2009?
Make the answer very short. 0.52. What is the ratio of the Enrollment rate (%) of Oman in 1999 to that in 2009?
Give a very brief answer. 0.88. What is the ratio of the Enrollment rate (%) of East Asia (developing only) in 2000 to that in 2001?
Keep it short and to the point. 1. What is the ratio of the Enrollment rate (%) of Niger in 2000 to that in 2001?
Your answer should be compact. 0.88. What is the ratio of the Enrollment rate (%) of Oman in 2000 to that in 2001?
Provide a succinct answer. 0.98. What is the ratio of the Enrollment rate (%) of East Asia (developing only) in 2000 to that in 2002?
Your answer should be very brief. 0.99. What is the ratio of the Enrollment rate (%) in Niger in 2000 to that in 2002?
Ensure brevity in your answer.  0.79. What is the ratio of the Enrollment rate (%) of Niger in 2000 to that in 2003?
Your answer should be compact. 0.71. What is the ratio of the Enrollment rate (%) of Oman in 2000 to that in 2003?
Ensure brevity in your answer.  1.04. What is the ratio of the Enrollment rate (%) in Niger in 2000 to that in 2009?
Offer a very short reply. 0.53. What is the ratio of the Enrollment rate (%) of Oman in 2000 to that in 2009?
Make the answer very short. 0.89. What is the ratio of the Enrollment rate (%) in Niger in 2001 to that in 2002?
Your answer should be very brief. 0.9. What is the ratio of the Enrollment rate (%) in Oman in 2001 to that in 2002?
Offer a terse response. 1.02. What is the ratio of the Enrollment rate (%) of East Asia (developing only) in 2001 to that in 2003?
Give a very brief answer. 1. What is the ratio of the Enrollment rate (%) of Niger in 2001 to that in 2003?
Offer a very short reply. 0.81. What is the ratio of the Enrollment rate (%) of Oman in 2001 to that in 2003?
Keep it short and to the point. 1.06. What is the ratio of the Enrollment rate (%) in Niger in 2001 to that in 2009?
Ensure brevity in your answer.  0.6. What is the ratio of the Enrollment rate (%) in Oman in 2001 to that in 2009?
Offer a terse response. 0.91. What is the ratio of the Enrollment rate (%) of East Asia (developing only) in 2002 to that in 2003?
Provide a succinct answer. 1. What is the ratio of the Enrollment rate (%) in Niger in 2002 to that in 2003?
Your answer should be compact. 0.9. What is the ratio of the Enrollment rate (%) in Oman in 2002 to that in 2003?
Your answer should be very brief. 1.05. What is the ratio of the Enrollment rate (%) in Niger in 2002 to that in 2009?
Provide a short and direct response. 0.67. What is the ratio of the Enrollment rate (%) in Oman in 2002 to that in 2009?
Make the answer very short. 0.89. What is the ratio of the Enrollment rate (%) of Niger in 2003 to that in 2009?
Your response must be concise. 0.74. What is the ratio of the Enrollment rate (%) in Oman in 2003 to that in 2009?
Give a very brief answer. 0.85. What is the difference between the highest and the second highest Enrollment rate (%) in East Asia (developing only)?
Ensure brevity in your answer.  0.4. What is the difference between the highest and the second highest Enrollment rate (%) of Niger?
Ensure brevity in your answer.  13.48. What is the difference between the highest and the second highest Enrollment rate (%) of Oman?
Your answer should be compact. 8.97. What is the difference between the highest and the lowest Enrollment rate (%) in East Asia (developing only)?
Ensure brevity in your answer.  7.12. What is the difference between the highest and the lowest Enrollment rate (%) in Niger?
Your answer should be very brief. 27.52. What is the difference between the highest and the lowest Enrollment rate (%) of Oman?
Your answer should be compact. 17.18. 